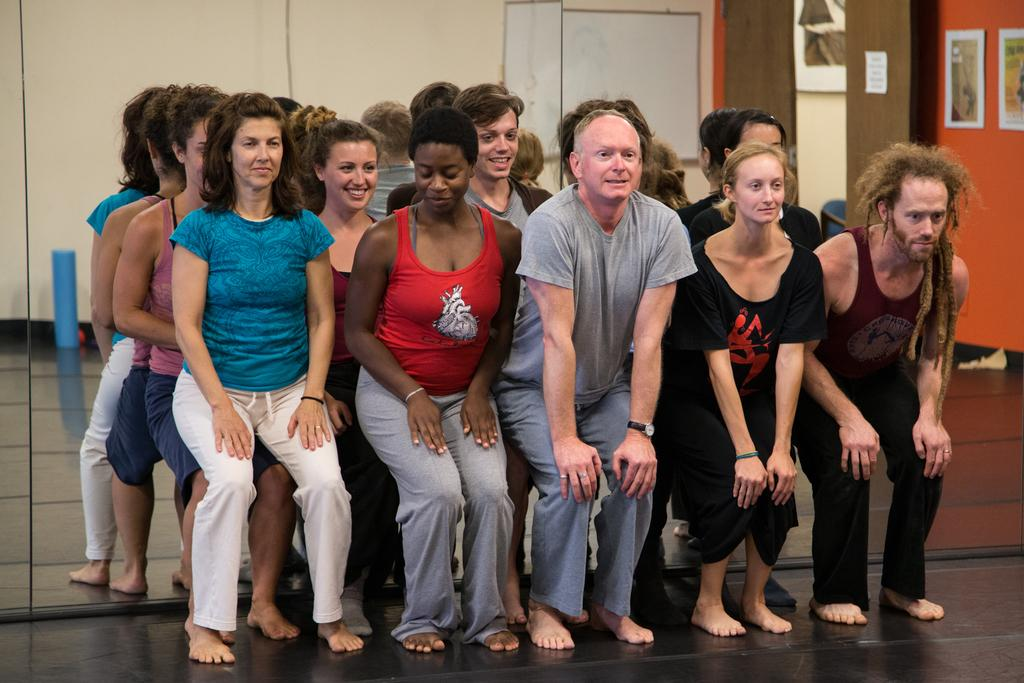What are the persons in the foreground of the image doing? The persons are doing wall chair exercises. Can you describe the exercise equipment in the image? Some persons are sitting on wall chairs. What is present in the foreground of the image? There is a mirror in the foreground of the image. What can be seen in the mirror? The wall is visible in the mirror, as well as some posters. How much money is being exchanged between the persons in the image? There is no indication of money being exchanged in the image; the persons are doing wall chair exercises. What type of balls are being used during the exercise in the image? There are no balls present in the image; the exercise involves wall chairs and wall chair exercises. 